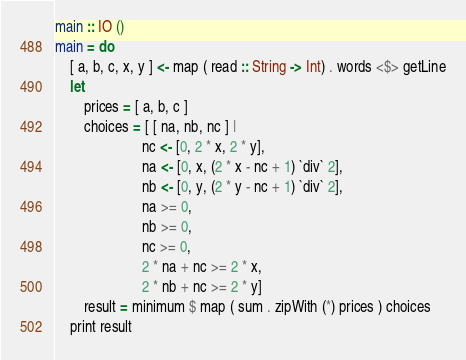Convert code to text. <code><loc_0><loc_0><loc_500><loc_500><_Haskell_>main :: IO ()
main = do
    [ a, b, c, x, y ] <- map ( read :: String -> Int) . words <$> getLine
    let
        prices = [ a, b, c ]
        choices = [ [ na, nb, nc ] |
                        nc <- [0, 2 * x, 2 * y],
                        na <- [0, x, (2 * x - nc + 1) `div` 2],
                        nb <- [0, y, (2 * y - nc + 1) `div` 2],
                        na >= 0,
                        nb >= 0,
                        nc >= 0,
                        2 * na + nc >= 2 * x,
                        2 * nb + nc >= 2 * y]
        result = minimum $ map ( sum . zipWith (*) prices ) choices
    print result
</code> 